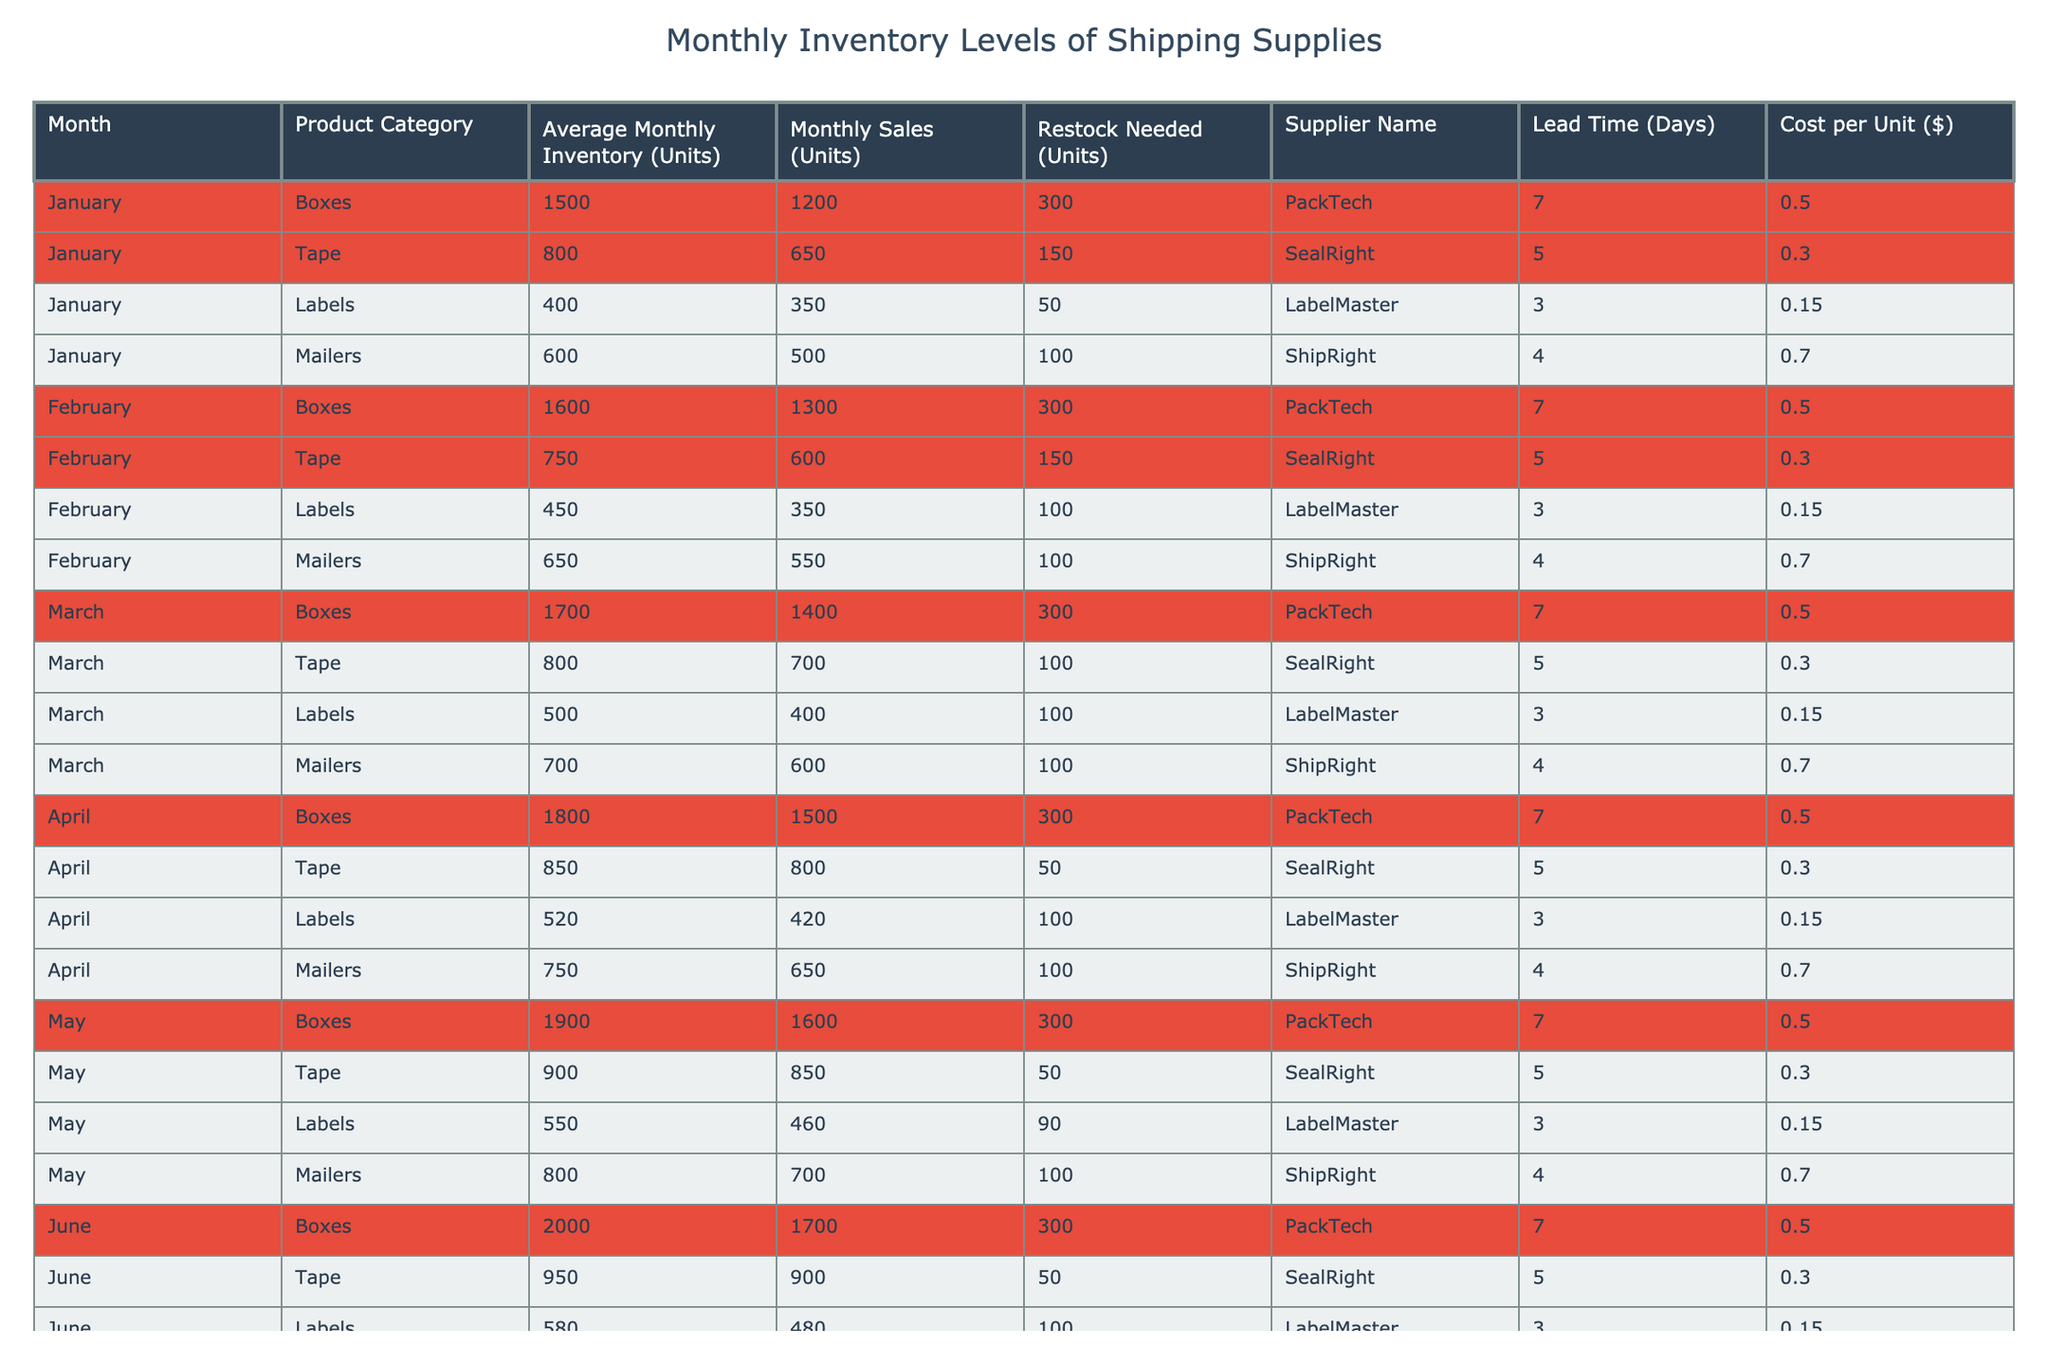What is the average monthly inventory of boxes for January? The average monthly inventory of boxes in January is listed as 1500 units in the table.
Answer: 1500 How many units of tape need to be restocked in February? The table shows that February has a restock needed for tape of 150 units.
Answer: 150 Which product category had the highest average monthly inventory in June? In June, boxes had the highest average monthly inventory at 2000 units, as indicated in the table.
Answer: Boxes What is the total restock needed for all product categories in April? For April, the restock needed for all categories is: Boxes (300) + Tape (50) + Labels (100) + Mailers (100) = 550 units total.
Answer: 550 Are there any product categories that need more than 100 units restocked in March? Yes, in March, the product categories with restock needed greater than 100 are Boxes (300), Tape (100), Labels (100), and Mailers (100) which all surpass this threshold.
Answer: Yes What is the trend in average monthly inventory for boxes from January to June? The average monthly inventory for boxes shows a steady increase: 1500 in January, 1600 in February, 1700 in March, 1800 in April, 1900 in May, and finally 2000 in June. This illustrates an upward trend over the months.
Answer: Increasing In which month did tape have the lowest average monthly inventory? The lowest average monthly inventory for tape was in February at 750 units.
Answer: February Is the cost per unit of mailers higher than that of boxes in any month? No, throughout all months presented in the table, the cost per unit of mailers ($0.70) is consistently higher than that of boxes ($0.50).
Answer: No What is the lead time for restocking labels in January? The lead time for restocking labels in January is indicated as 3 days in the table.
Answer: 3 days How much more inventory of mailers will be needed in May compared to April? In May, the inventory needed for mailers is 100 units. In April, it is also 100 units. Therefore, the difference is 100 - 100 = 0 units more needed in May compared to April.
Answer: 0 units 